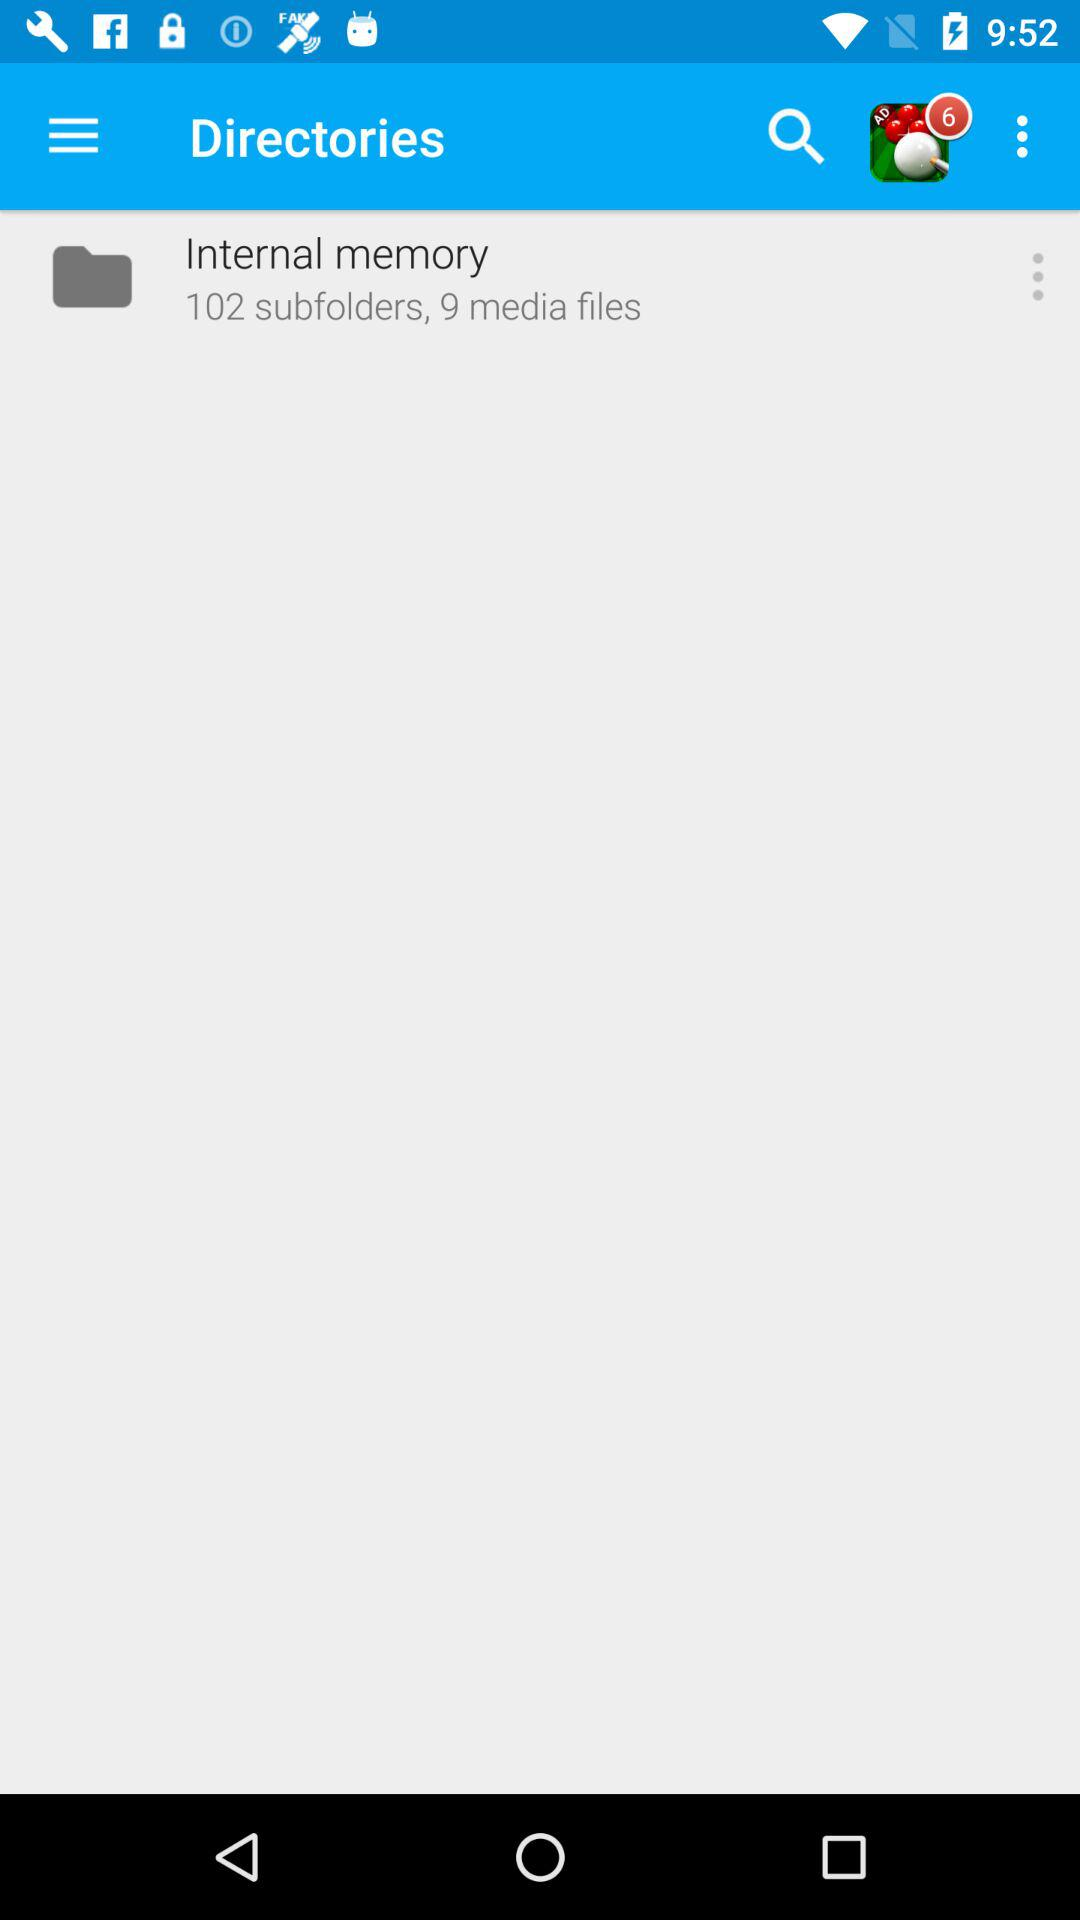How many media files are there in the internal memory? There are 9 media files. 